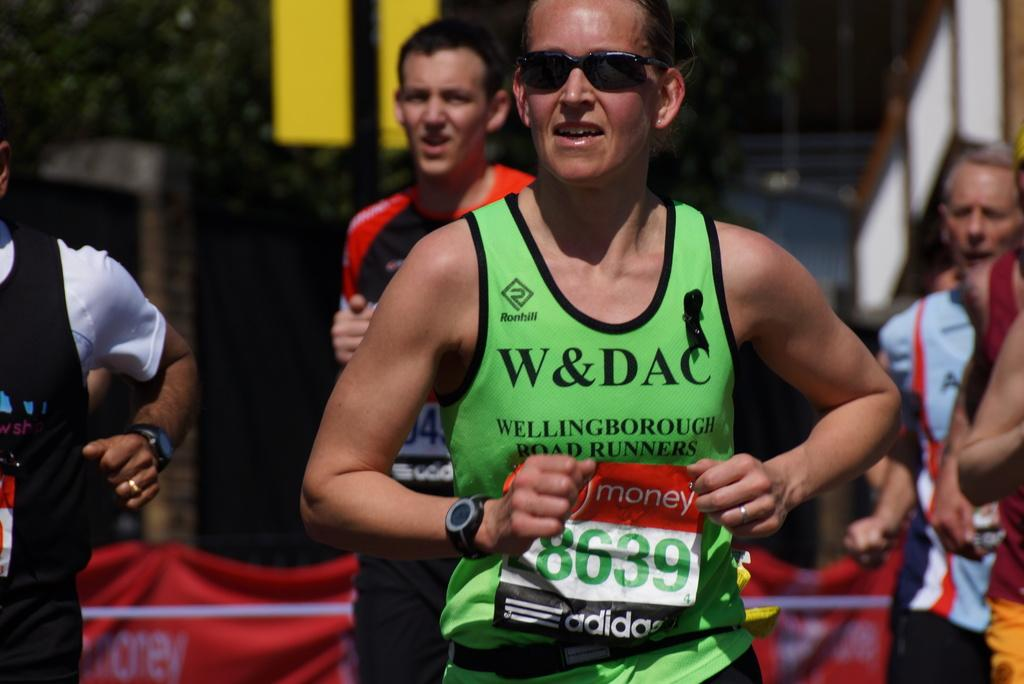Provide a one-sentence caption for the provided image. A girl runs with a Wellingborough tank top. 